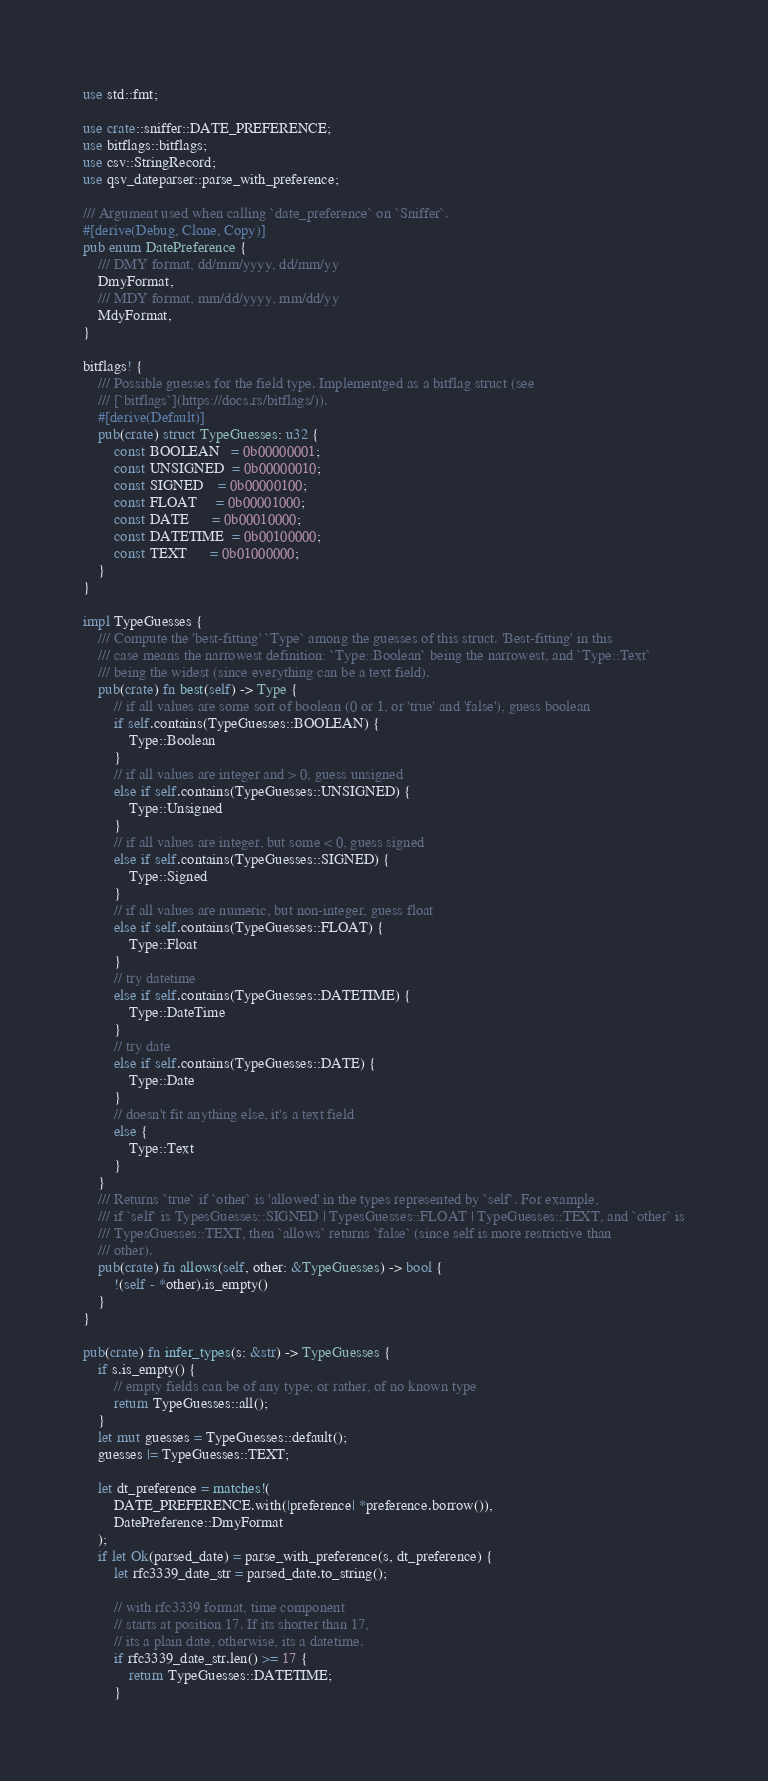<code> <loc_0><loc_0><loc_500><loc_500><_Rust_>use std::fmt;

use crate::sniffer::DATE_PREFERENCE;
use bitflags::bitflags;
use csv::StringRecord;
use qsv_dateparser::parse_with_preference;

/// Argument used when calling `date_preference` on `Sniffer`.
#[derive(Debug, Clone, Copy)]
pub enum DatePreference {
    /// DMY format, dd/mm/yyyy, dd/mm/yy
    DmyFormat,
    /// MDY format, mm/dd/yyyy, mm/dd/yy
    MdyFormat,
}

bitflags! {
    /// Possible guesses for the field type. Implementged as a bitflag struct (see
    /// [`bitflags`](https://docs.rs/bitflags/)).
    #[derive(Default)]
    pub(crate) struct TypeGuesses: u32 {
        const BOOLEAN   = 0b00000001;
        const UNSIGNED  = 0b00000010;
        const SIGNED    = 0b00000100;
        const FLOAT     = 0b00001000;
        const DATE      = 0b00010000;
        const DATETIME  = 0b00100000;
        const TEXT      = 0b01000000;
    }
}

impl TypeGuesses {
    /// Compute the 'best-fitting' `Type` among the guesses of this struct. 'Best-fitting' in this
    /// case means the narrowest definition: `Type::Boolean` being the narrowest, and `Type::Text`
    /// being the widest (since everything can be a text field).
    pub(crate) fn best(self) -> Type {
        // if all values are some sort of boolean (0 or 1, or 'true' and 'false'), guess boolean
        if self.contains(TypeGuesses::BOOLEAN) {
            Type::Boolean
        }
        // if all values are integer and > 0, guess unsigned
        else if self.contains(TypeGuesses::UNSIGNED) {
            Type::Unsigned
        }
        // if all values are integer, but some < 0, guess signed
        else if self.contains(TypeGuesses::SIGNED) {
            Type::Signed
        }
        // if all values are numeric, but non-integer, guess float
        else if self.contains(TypeGuesses::FLOAT) {
            Type::Float
        }
        // try datetime
        else if self.contains(TypeGuesses::DATETIME) {
            Type::DateTime
        }
        // try date
        else if self.contains(TypeGuesses::DATE) {
            Type::Date
        }
        // doesn't fit anything else, it's a text field
        else {
            Type::Text
        }
    }
    /// Returns `true` if `other` is 'allowed' in the types represented by `self`. For example,
    /// if `self` is TypesGuesses::SIGNED | TypesGuesses::FLOAT | TypeGuesses::TEXT, and `other` is
    /// TypesGuesses::TEXT, then `allows` returns `false` (since self is more restrictive than
    /// other).
    pub(crate) fn allows(self, other: &TypeGuesses) -> bool {
        !(self - *other).is_empty()
    }
}

pub(crate) fn infer_types(s: &str) -> TypeGuesses {
    if s.is_empty() {
        // empty fields can be of any type; or rather, of no known type
        return TypeGuesses::all();
    }
    let mut guesses = TypeGuesses::default();
    guesses |= TypeGuesses::TEXT;

    let dt_preference = matches!(
        DATE_PREFERENCE.with(|preference| *preference.borrow()),
        DatePreference::DmyFormat
    );
    if let Ok(parsed_date) = parse_with_preference(s, dt_preference) {
        let rfc3339_date_str = parsed_date.to_string();

        // with rfc3339 format, time component
        // starts at position 17. If its shorter than 17,
        // its a plain date, otherwise, its a datetime.
        if rfc3339_date_str.len() >= 17 {
            return TypeGuesses::DATETIME;
        }</code> 